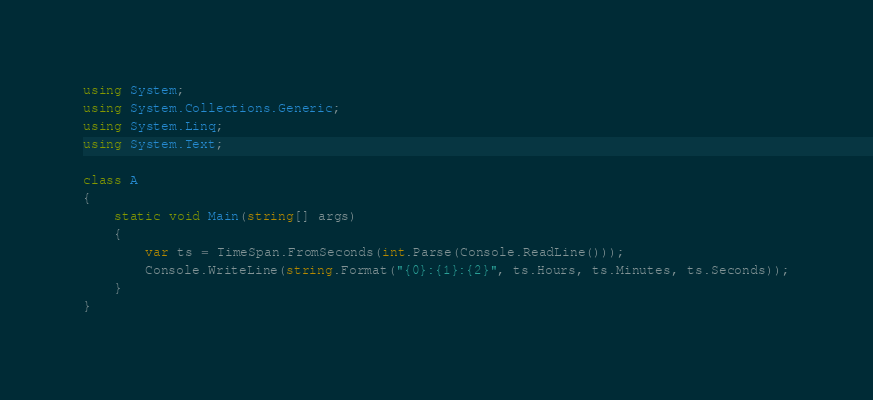Convert code to text. <code><loc_0><loc_0><loc_500><loc_500><_C#_>using System;
using System.Collections.Generic;
using System.Linq;
using System.Text;

class A
{
    static void Main(string[] args)
    {
        var ts = TimeSpan.FromSeconds(int.Parse(Console.ReadLine()));
        Console.WriteLine(string.Format("{0}:{1}:{2}", ts.Hours, ts.Minutes, ts.Seconds));
    }
}</code> 